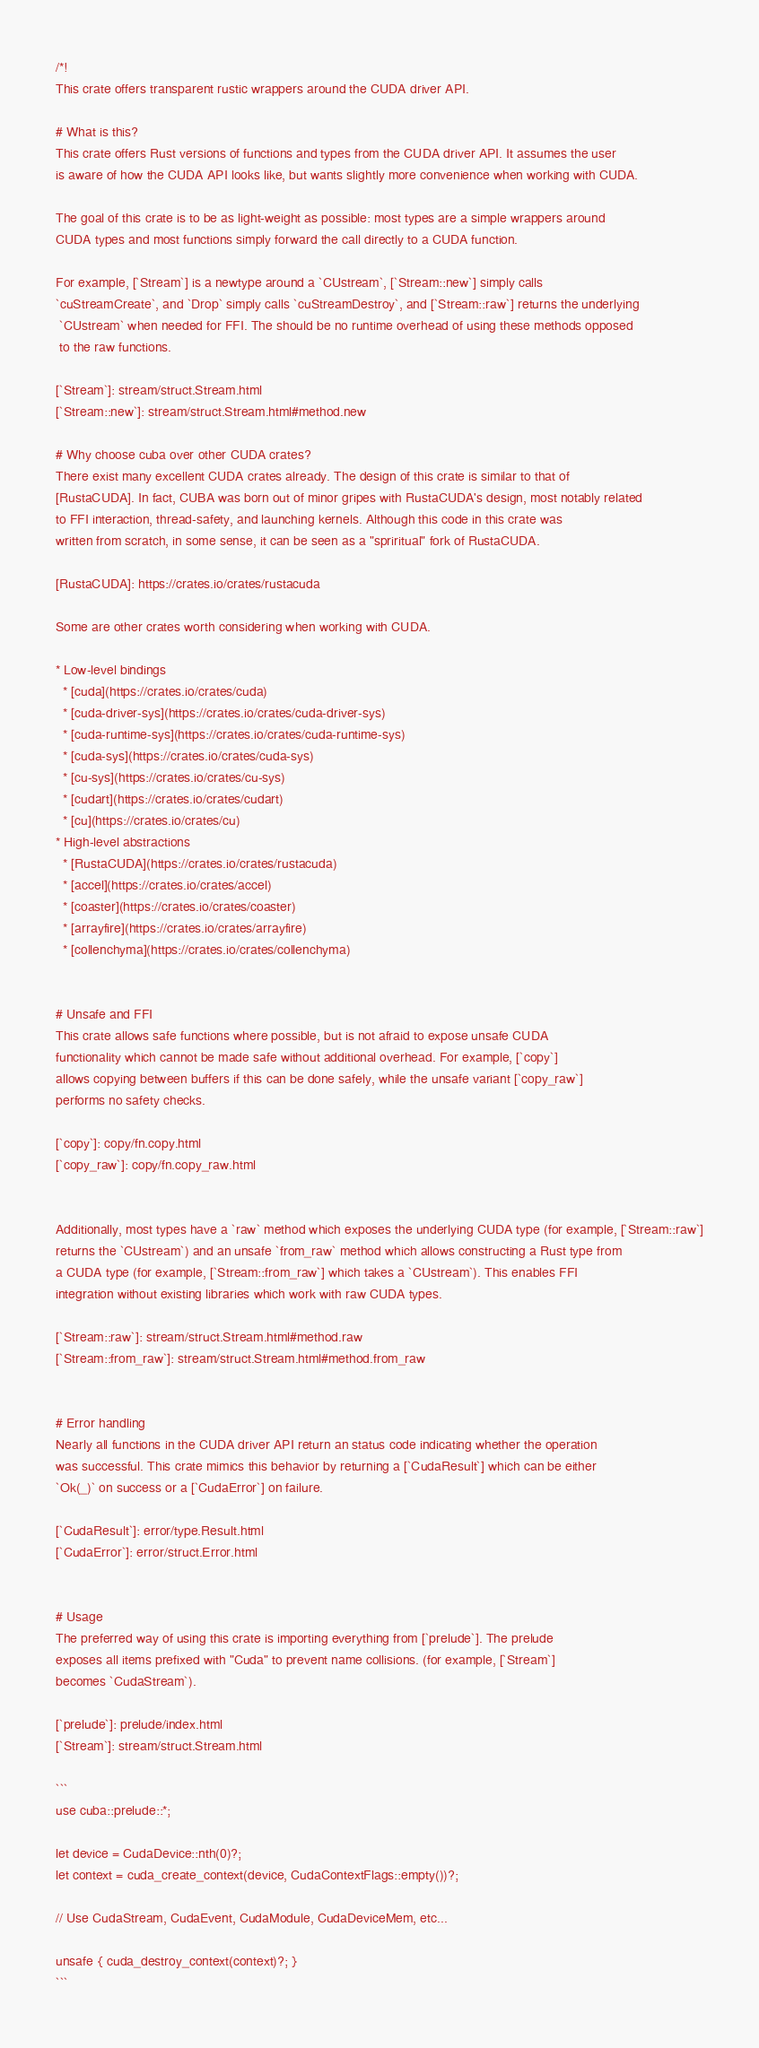<code> <loc_0><loc_0><loc_500><loc_500><_Rust_>/*!
This crate offers transparent rustic wrappers around the CUDA driver API.

# What is this?
This crate offers Rust versions of functions and types from the CUDA driver API. It assumes the user
is aware of how the CUDA API looks like, but wants slightly more convenience when working with CUDA.

The goal of this crate is to be as light-weight as possible: most types are a simple wrappers around
CUDA types and most functions simply forward the call directly to a CUDA function.

For example, [`Stream`] is a newtype around a `CUstream`, [`Stream::new`] simply calls
`cuStreamCreate`, and `Drop` simply calls `cuStreamDestroy`, and [`Stream::raw`] returns the underlying
 `CUstream` when needed for FFI. The should be no runtime overhead of using these methods opposed
 to the raw functions.

[`Stream`]: stream/struct.Stream.html
[`Stream::new`]: stream/struct.Stream.html#method.new

# Why choose cuba over other CUDA crates?
There exist many excellent CUDA crates already. The design of this crate is similar to that of
[RustaCUDA]. In fact, CUBA was born out of minor gripes with RustaCUDA's design, most notably related
to FFI interaction, thread-safety, and launching kernels. Although this code in this crate was
written from scratch, in some sense, it can be seen as a "spriritual" fork of RustaCUDA.

[RustaCUDA]: https://crates.io/crates/rustacuda

Some are other crates worth considering when working with CUDA.

* Low-level bindings
  * [cuda](https://crates.io/crates/cuda)
  * [cuda-driver-sys](https://crates.io/crates/cuda-driver-sys)
  * [cuda-runtime-sys](https://crates.io/crates/cuda-runtime-sys)
  * [cuda-sys](https://crates.io/crates/cuda-sys)
  * [cu-sys](https://crates.io/crates/cu-sys)
  * [cudart](https://crates.io/crates/cudart)
  * [cu](https://crates.io/crates/cu)
* High-level abstractions
  * [RustaCUDA](https://crates.io/crates/rustacuda)
  * [accel](https://crates.io/crates/accel)
  * [coaster](https://crates.io/crates/coaster)
  * [arrayfire](https://crates.io/crates/arrayfire)
  * [collenchyma](https://crates.io/crates/collenchyma)


# Unsafe and FFI
This crate allows safe functions where possible, but is not afraid to expose unsafe CUDA
functionality which cannot be made safe without additional overhead. For example, [`copy`]
allows copying between buffers if this can be done safely, while the unsafe variant [`copy_raw`]
performs no safety checks.

[`copy`]: copy/fn.copy.html
[`copy_raw`]: copy/fn.copy_raw.html


Additionally, most types have a `raw` method which exposes the underlying CUDA type (for example, [`Stream::raw`]
returns the `CUstream`) and an unsafe `from_raw` method which allows constructing a Rust type from
a CUDA type (for example, [`Stream::from_raw`] which takes a `CUstream`). This enables FFI
integration without existing libraries which work with raw CUDA types.

[`Stream::raw`]: stream/struct.Stream.html#method.raw
[`Stream::from_raw`]: stream/struct.Stream.html#method.from_raw


# Error handling
Nearly all functions in the CUDA driver API return an status code indicating whether the operation
was successful. This crate mimics this behavior by returning a [`CudaResult`] which can be either
`Ok(_)` on success or a [`CudaError`] on failure.

[`CudaResult`]: error/type.Result.html
[`CudaError`]: error/struct.Error.html


# Usage
The preferred way of using this crate is importing everything from [`prelude`]. The prelude
exposes all items prefixed with "Cuda" to prevent name collisions. (for example, [`Stream`]
becomes `CudaStream`).

[`prelude`]: prelude/index.html
[`Stream`]: stream/struct.Stream.html

```
use cuba::prelude::*;

let device = CudaDevice::nth(0)?;
let context = cuda_create_context(device, CudaContextFlags::empty())?;

// Use CudaStream, CudaEvent, CudaModule, CudaDeviceMem, etc...

unsafe { cuda_destroy_context(context)?; }
```
</code> 